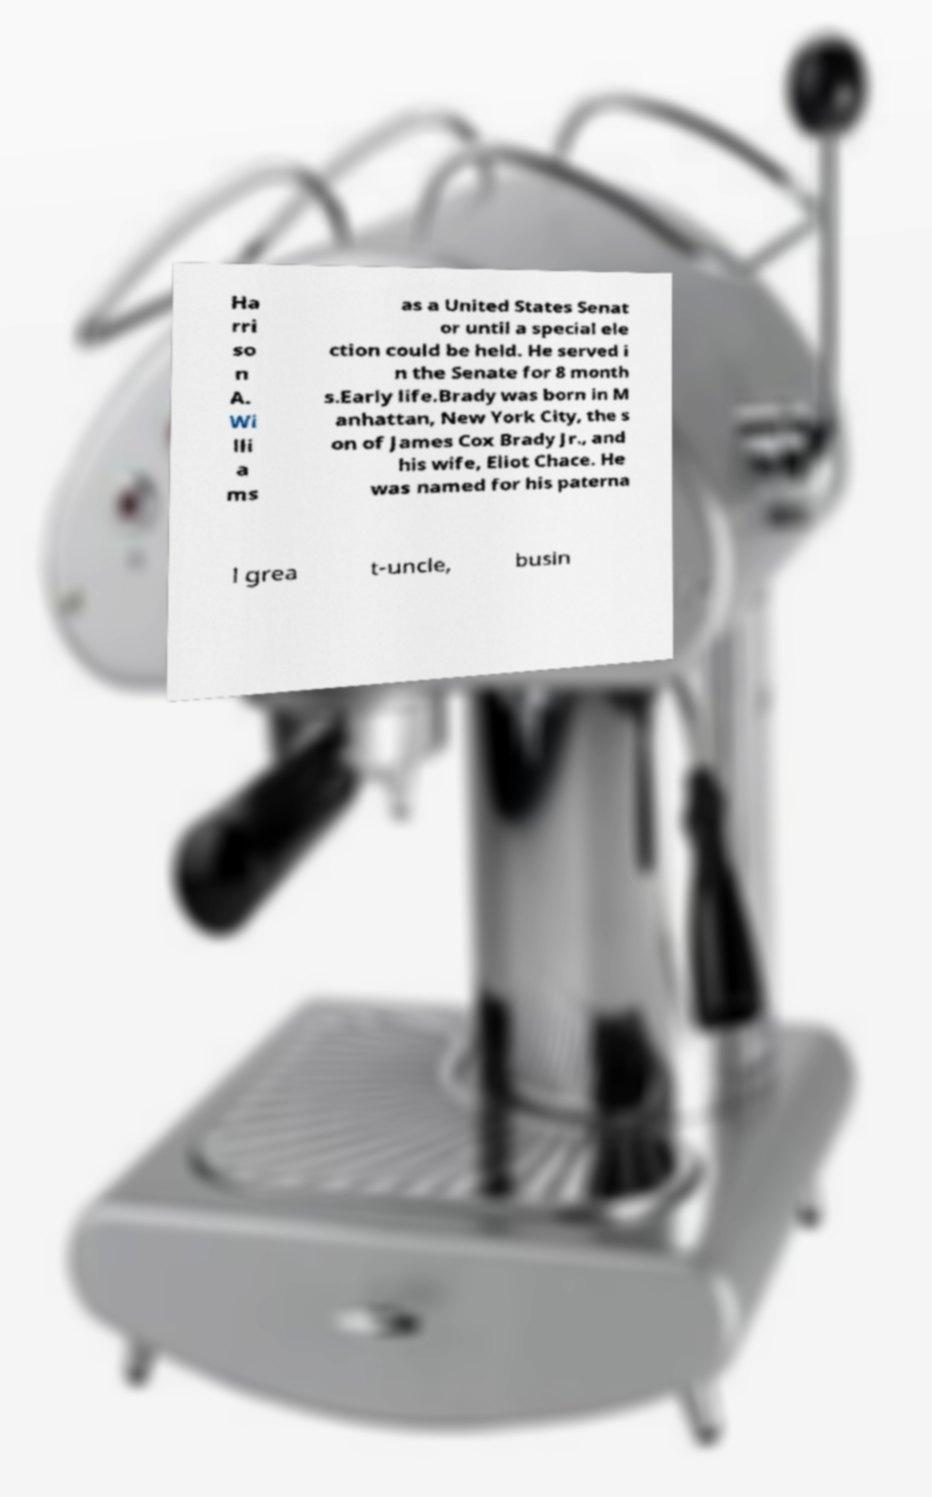I need the written content from this picture converted into text. Can you do that? Ha rri so n A. Wi lli a ms as a United States Senat or until a special ele ction could be held. He served i n the Senate for 8 month s.Early life.Brady was born in M anhattan, New York City, the s on of James Cox Brady Jr., and his wife, Eliot Chace. He was named for his paterna l grea t-uncle, busin 